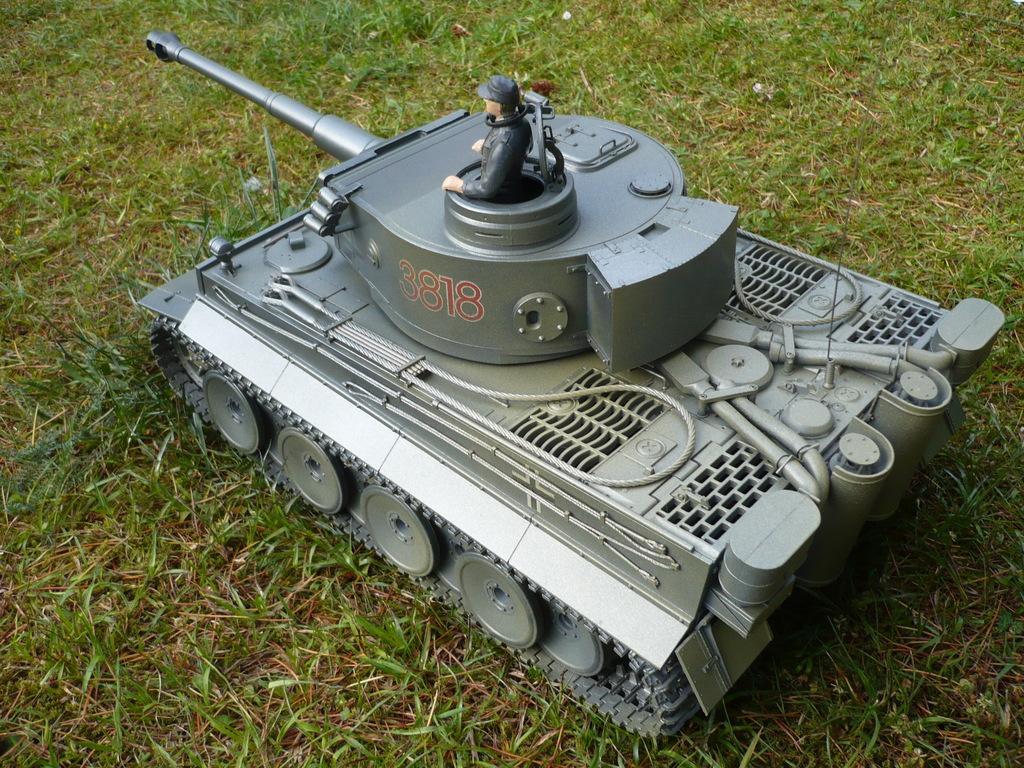Describe this image in one or two sentences. In this picture we can see a toy on the grass. 